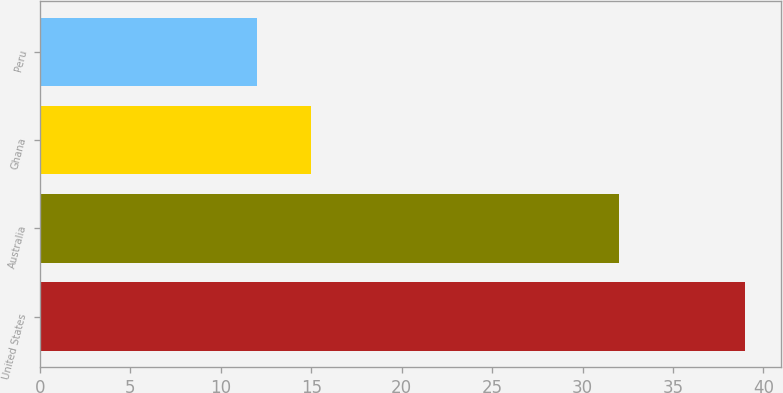<chart> <loc_0><loc_0><loc_500><loc_500><bar_chart><fcel>United States<fcel>Australia<fcel>Ghana<fcel>Peru<nl><fcel>39<fcel>32<fcel>15<fcel>12<nl></chart> 